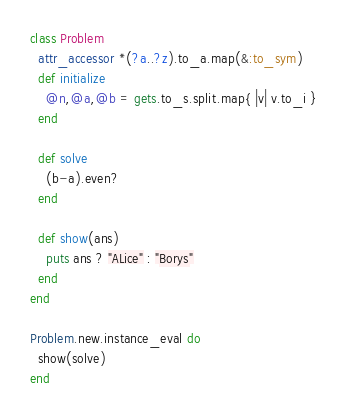<code> <loc_0><loc_0><loc_500><loc_500><_Ruby_>class Problem
  attr_accessor *(?a..?z).to_a.map(&:to_sym)
  def initialize
    @n,@a,@b = gets.to_s.split.map{ |v| v.to_i }
  end

  def solve
    (b-a).even?
  end

  def show(ans)
    puts ans ? "ALice" : "Borys"
  end
end

Problem.new.instance_eval do
  show(solve)
end</code> 